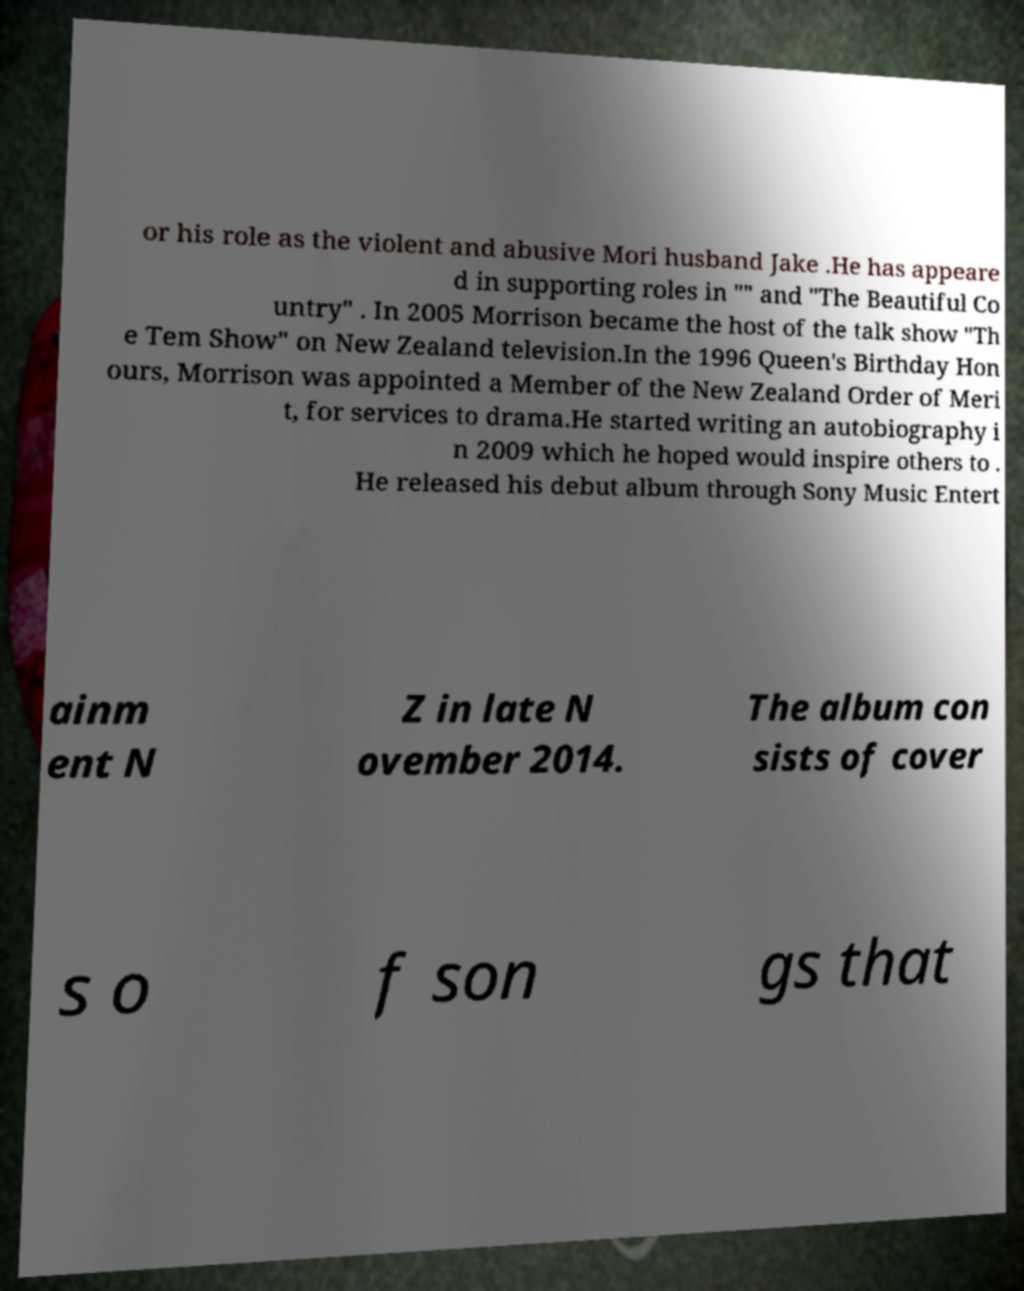Could you extract and type out the text from this image? or his role as the violent and abusive Mori husband Jake .He has appeare d in supporting roles in "" and "The Beautiful Co untry" . In 2005 Morrison became the host of the talk show "Th e Tem Show" on New Zealand television.In the 1996 Queen's Birthday Hon ours, Morrison was appointed a Member of the New Zealand Order of Meri t, for services to drama.He started writing an autobiography i n 2009 which he hoped would inspire others to . He released his debut album through Sony Music Entert ainm ent N Z in late N ovember 2014. The album con sists of cover s o f son gs that 